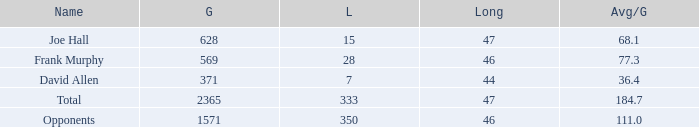Which Avg/G has a Name of david allen, and a Gain larger than 371? None. 